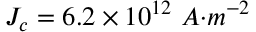<formula> <loc_0><loc_0><loc_500><loc_500>J _ { c } = 6 . 2 \times { 1 0 } ^ { 1 2 } { \ A } { m } } ^ { - 2 }</formula> 